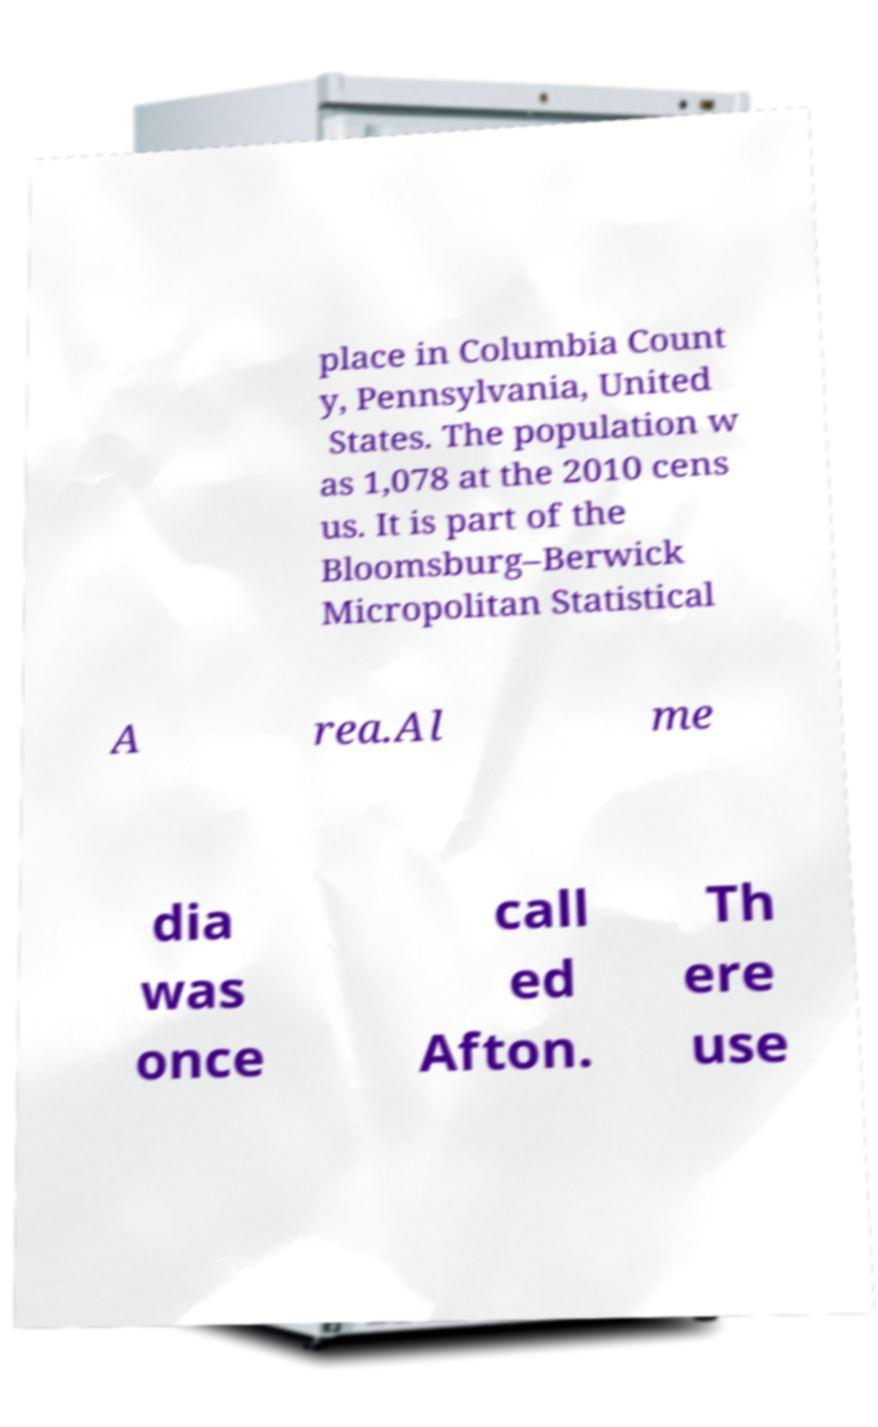Please read and relay the text visible in this image. What does it say? place in Columbia Count y, Pennsylvania, United States. The population w as 1,078 at the 2010 cens us. It is part of the Bloomsburg–Berwick Micropolitan Statistical A rea.Al me dia was once call ed Afton. Th ere use 